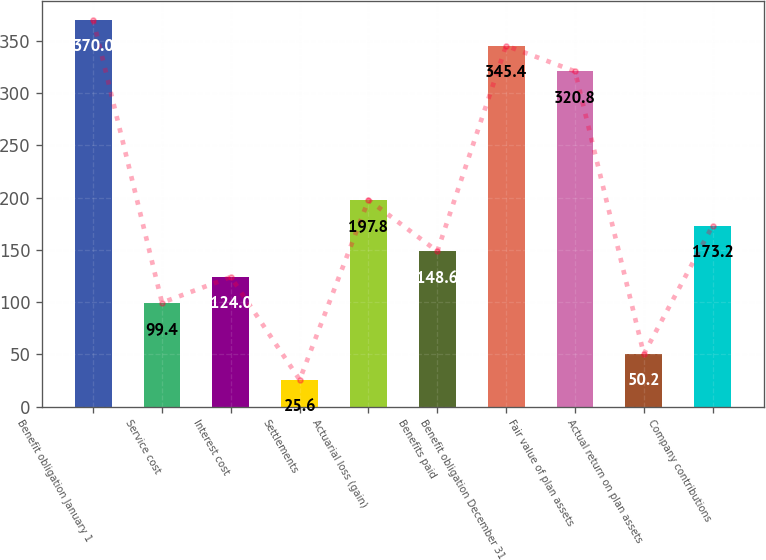Convert chart to OTSL. <chart><loc_0><loc_0><loc_500><loc_500><bar_chart><fcel>Benefit obligation January 1<fcel>Service cost<fcel>Interest cost<fcel>Settlements<fcel>Actuarial loss (gain)<fcel>Benefits paid<fcel>Benefit obligation December 31<fcel>Fair value of plan assets<fcel>Actual return on plan assets<fcel>Company contributions<nl><fcel>370<fcel>99.4<fcel>124<fcel>25.6<fcel>197.8<fcel>148.6<fcel>345.4<fcel>320.8<fcel>50.2<fcel>173.2<nl></chart> 